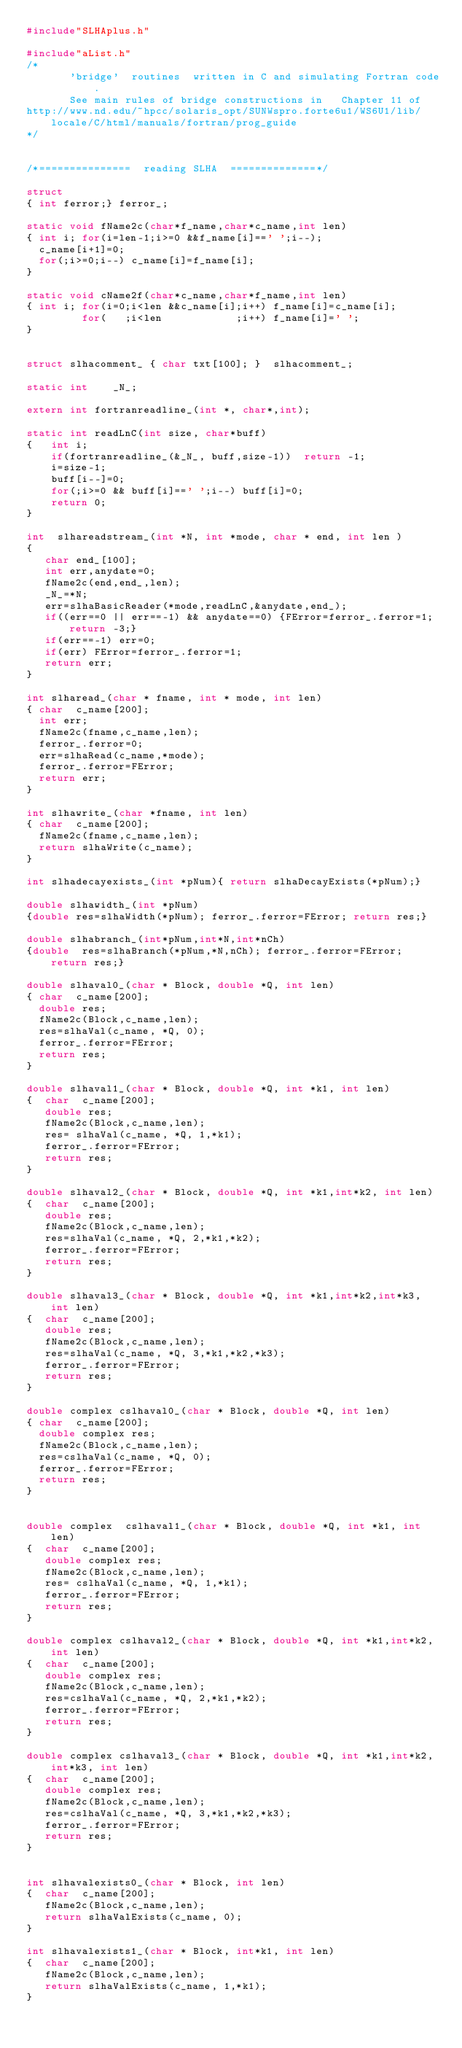Convert code to text. <code><loc_0><loc_0><loc_500><loc_500><_C_>#include"SLHAplus.h"

#include"aList.h"
/*
       'bridge'  routines  written in C and simulating Fortran code.
       See main rules of bridge constructions in   Chapter 11 of
http://www.nd.edu/~hpcc/solaris_opt/SUNWspro.forte6u1/WS6U1/lib/locale/C/html/manuals/fortran/prog_guide
*/


/*===============  reading SLHA  ==============*/ 

struct 
{ int ferror;} ferror_;

static void fName2c(char*f_name,char*c_name,int len)
{ int i; for(i=len-1;i>=0 &&f_name[i]==' ';i--);
  c_name[i+1]=0;
  for(;i>=0;i--) c_name[i]=f_name[i];
}

static void cName2f(char*c_name,char*f_name,int len)
{ int i; for(i=0;i<len &&c_name[i];i++) f_name[i]=c_name[i];
         for(   ;i<len            ;i++) f_name[i]=' ';
}
         

struct slhacomment_ { char txt[100]; }  slhacomment_;

static int    _N_;

extern int fortranreadline_(int *, char*,int);

static int readLnC(int size, char*buff)
{   int i;
    if(fortranreadline_(&_N_, buff,size-1))  return -1;
    i=size-1;
    buff[i--]=0;
    for(;i>=0 && buff[i]==' ';i--) buff[i]=0;                                                          
    return 0;
}

int  slhareadstream_(int *N, int *mode, char * end, int len )
{
   char end_[100];
   int err,anydate=0;
   fName2c(end,end_,len);
   _N_=*N;
   err=slhaBasicReader(*mode,readLnC,&anydate,end_);
   if((err==0 || err==-1) && anydate==0) {FError=ferror_.ferror=1; return -3;}
   if(err==-1) err=0; 
   if(err) FError=ferror_.ferror=1;
   return err;
}

int slharead_(char * fname, int * mode, int len)
{ char  c_name[200];
  int err;
  fName2c(fname,c_name,len);
  ferror_.ferror=0;
  err=slhaRead(c_name,*mode);
  ferror_.ferror=FError;
  return err;
}

int slhawrite_(char *fname, int len)
{ char  c_name[200];
  fName2c(fname,c_name,len);
  return slhaWrite(c_name);
}

int slhadecayexists_(int *pNum){ return slhaDecayExists(*pNum);}

double slhawidth_(int *pNum)
{double res=slhaWidth(*pNum); ferror_.ferror=FError; return res;}

double slhabranch_(int*pNum,int*N,int*nCh)
{double  res=slhaBranch(*pNum,*N,nCh); ferror_.ferror=FError; return res;}

double slhaval0_(char * Block, double *Q, int len)
{ char  c_name[200];
  double res;
  fName2c(Block,c_name,len);
  res=slhaVal(c_name, *Q, 0);
  ferror_.ferror=FError;
  return res;
} 

double slhaval1_(char * Block, double *Q, int *k1, int len)
{  char  c_name[200];
   double res;
   fName2c(Block,c_name,len);
   res= slhaVal(c_name, *Q, 1,*k1);
   ferror_.ferror=FError;
   return res;
} 

double slhaval2_(char * Block, double *Q, int *k1,int*k2, int len)
{  char  c_name[200];
   double res;
   fName2c(Block,c_name,len);
   res=slhaVal(c_name, *Q, 2,*k1,*k2); 
   ferror_.ferror=FError;
   return res;       
} 

double slhaval3_(char * Block, double *Q, int *k1,int*k2,int*k3, int len)
{  char  c_name[200];
   double res;
   fName2c(Block,c_name,len);
   res=slhaVal(c_name, *Q, 3,*k1,*k2,*k3);
   ferror_.ferror=FError;
   return res;       
} 

double complex cslhaval0_(char * Block, double *Q, int len)
{ char  c_name[200];
  double complex res;
  fName2c(Block,c_name,len);
  res=cslhaVal(c_name, *Q, 0);
  ferror_.ferror=FError;
  return res;
} 


double complex  cslhaval1_(char * Block, double *Q, int *k1, int len)
{  char  c_name[200];
   double complex res;
   fName2c(Block,c_name,len);
   res= cslhaVal(c_name, *Q, 1,*k1);
   ferror_.ferror=FError;
   return res;
} 

double complex cslhaval2_(char * Block, double *Q, int *k1,int*k2, int len)
{  char  c_name[200];
   double complex res;
   fName2c(Block,c_name,len);
   res=cslhaVal(c_name, *Q, 2,*k1,*k2); 
   ferror_.ferror=FError;
   return res;       
} 

double complex cslhaval3_(char * Block, double *Q, int *k1,int*k2,int*k3, int len)
{  char  c_name[200];
   double complex res;
   fName2c(Block,c_name,len);
   res=cslhaVal(c_name, *Q, 3,*k1,*k2,*k3);
   ferror_.ferror=FError;
   return res;       
} 

 
int slhavalexists0_(char * Block, int len)
{  char  c_name[200];
   fName2c(Block,c_name,len);
   return slhaValExists(c_name, 0);
}

int slhavalexists1_(char * Block, int*k1, int len)
{  char  c_name[200];
   fName2c(Block,c_name,len);
   return slhaValExists(c_name, 1,*k1);
}
</code> 